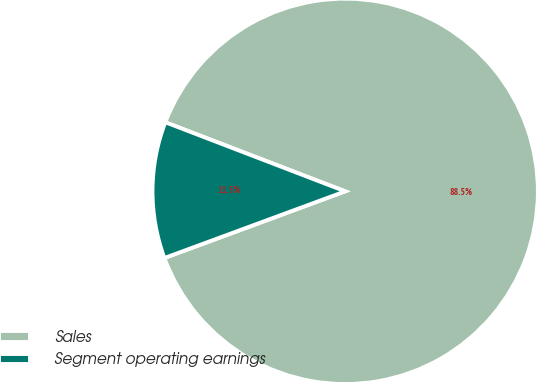Convert chart to OTSL. <chart><loc_0><loc_0><loc_500><loc_500><pie_chart><fcel>Sales<fcel>Segment operating earnings<nl><fcel>88.54%<fcel>11.46%<nl></chart> 